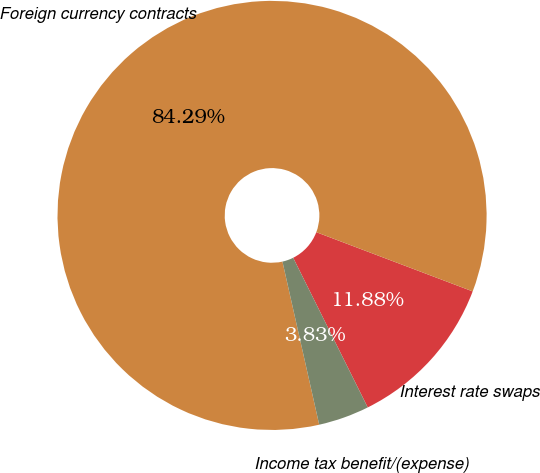<chart> <loc_0><loc_0><loc_500><loc_500><pie_chart><fcel>Interest rate swaps<fcel>Foreign currency contracts<fcel>Income tax benefit/(expense)<nl><fcel>11.88%<fcel>84.29%<fcel>3.83%<nl></chart> 